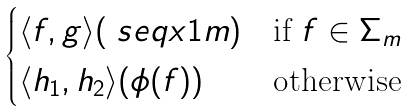<formula> <loc_0><loc_0><loc_500><loc_500>\begin{cases} \langle f , g \rangle ( \ s e q x 1 m ) & \text {if } f \in \Sigma _ { m } \\ \langle h _ { 1 } , h _ { 2 } \rangle ( \phi ( f ) ) & \text {otherwise} \end{cases}</formula> 